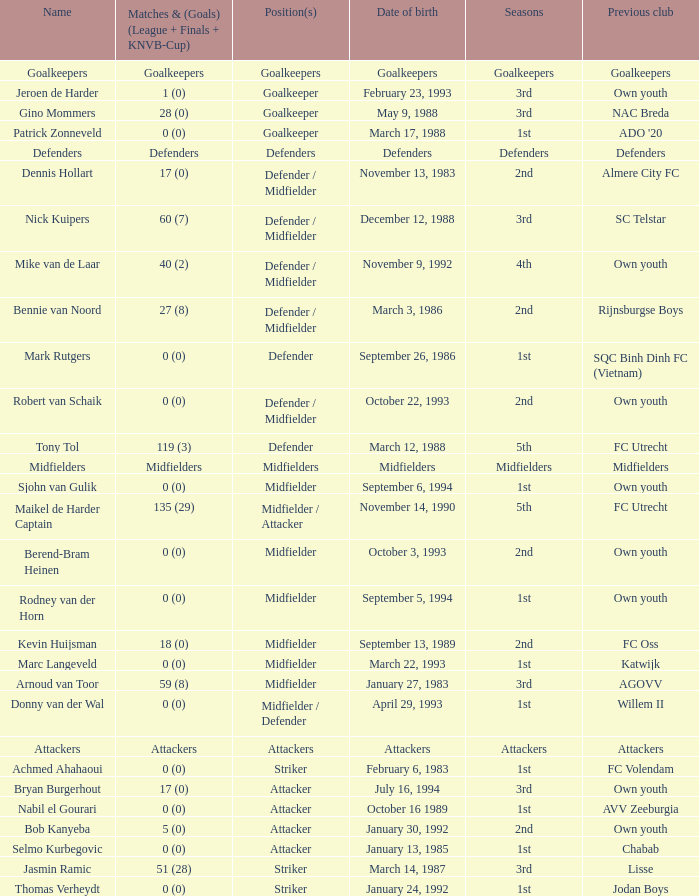Parse the full table. {'header': ['Name', 'Matches & (Goals) (League + Finals + KNVB-Cup)', 'Position(s)', 'Date of birth', 'Seasons', 'Previous club'], 'rows': [['Goalkeepers', 'Goalkeepers', 'Goalkeepers', 'Goalkeepers', 'Goalkeepers', 'Goalkeepers'], ['Jeroen de Harder', '1 (0)', 'Goalkeeper', 'February 23, 1993', '3rd', 'Own youth'], ['Gino Mommers', '28 (0)', 'Goalkeeper', 'May 9, 1988', '3rd', 'NAC Breda'], ['Patrick Zonneveld', '0 (0)', 'Goalkeeper', 'March 17, 1988', '1st', "ADO '20"], ['Defenders', 'Defenders', 'Defenders', 'Defenders', 'Defenders', 'Defenders'], ['Dennis Hollart', '17 (0)', 'Defender / Midfielder', 'November 13, 1983', '2nd', 'Almere City FC'], ['Nick Kuipers', '60 (7)', 'Defender / Midfielder', 'December 12, 1988', '3rd', 'SC Telstar'], ['Mike van de Laar', '40 (2)', 'Defender / Midfielder', 'November 9, 1992', '4th', 'Own youth'], ['Bennie van Noord', '27 (8)', 'Defender / Midfielder', 'March 3, 1986', '2nd', 'Rijnsburgse Boys'], ['Mark Rutgers', '0 (0)', 'Defender', 'September 26, 1986', '1st', 'SQC Binh Dinh FC (Vietnam)'], ['Robert van Schaik', '0 (0)', 'Defender / Midfielder', 'October 22, 1993', '2nd', 'Own youth'], ['Tony Tol', '119 (3)', 'Defender', 'March 12, 1988', '5th', 'FC Utrecht'], ['Midfielders', 'Midfielders', 'Midfielders', 'Midfielders', 'Midfielders', 'Midfielders'], ['Sjohn van Gulik', '0 (0)', 'Midfielder', 'September 6, 1994', '1st', 'Own youth'], ['Maikel de Harder Captain', '135 (29)', 'Midfielder / Attacker', 'November 14, 1990', '5th', 'FC Utrecht'], ['Berend-Bram Heinen', '0 (0)', 'Midfielder', 'October 3, 1993', '2nd', 'Own youth'], ['Rodney van der Horn', '0 (0)', 'Midfielder', 'September 5, 1994', '1st', 'Own youth'], ['Kevin Huijsman', '18 (0)', 'Midfielder', 'September 13, 1989', '2nd', 'FC Oss'], ['Marc Langeveld', '0 (0)', 'Midfielder', 'March 22, 1993', '1st', 'Katwijk'], ['Arnoud van Toor', '59 (8)', 'Midfielder', 'January 27, 1983', '3rd', 'AGOVV'], ['Donny van der Wal', '0 (0)', 'Midfielder / Defender', 'April 29, 1993', '1st', 'Willem II'], ['Attackers', 'Attackers', 'Attackers', 'Attackers', 'Attackers', 'Attackers'], ['Achmed Ahahaoui', '0 (0)', 'Striker', 'February 6, 1983', '1st', 'FC Volendam'], ['Bryan Burgerhout', '17 (0)', 'Attacker', 'July 16, 1994', '3rd', 'Own youth'], ['Nabil el Gourari', '0 (0)', 'Attacker', 'October 16 1989', '1st', 'AVV Zeeburgia'], ['Bob Kanyeba', '5 (0)', 'Attacker', 'January 30, 1992', '2nd', 'Own youth'], ['Selmo Kurbegovic', '0 (0)', 'Attacker', 'January 13, 1985', '1st', 'Chabab'], ['Jasmin Ramic', '51 (28)', 'Striker', 'March 14, 1987', '3rd', 'Lisse'], ['Thomas Verheydt', '0 (0)', 'Striker', 'January 24, 1992', '1st', 'Jodan Boys']]} What is the date of birth of the goalkeeper from the 1st season? March 17, 1988. 